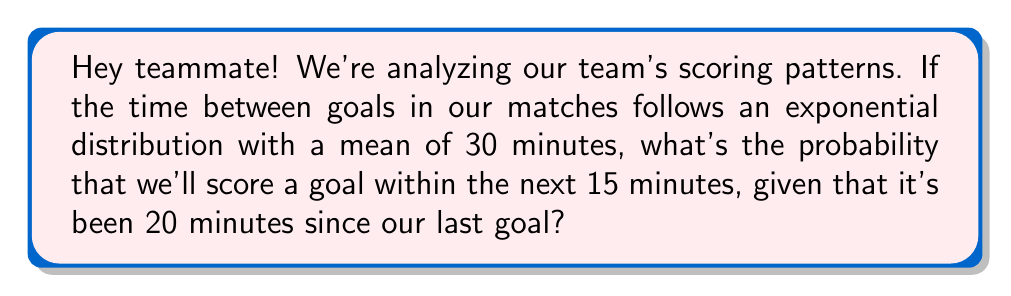Show me your answer to this math problem. Alright, let's break this down step-by-step:

1) The exponential distribution is memoryless, which means the probability of an event occurring in the next time interval is independent of how much time has already passed. So, the fact that 20 minutes have passed doesn't affect our calculation.

2) We're given that the mean time between goals is 30 minutes. For an exponential distribution, the mean is equal to $\frac{1}{\lambda}$, where $\lambda$ is the rate parameter. So:

   $\frac{1}{\lambda} = 30$
   $\lambda = \frac{1}{30}$

3) The probability of scoring a goal within time $t$ is given by the cumulative distribution function (CDF) of the exponential distribution:

   $P(T \leq t) = 1 - e^{-\lambda t}$

4) We want to find the probability of scoring within the next 15 minutes, so we'll use $t = 15$:

   $P(T \leq 15) = 1 - e^{-\frac{1}{30} \cdot 15}$

5) Let's calculate this:

   $P(T \leq 15) = 1 - e^{-0.5}$
                 $= 1 - 0.6065$
                 $= 0.3935$

6) Converting to a percentage:

   $0.3935 \cdot 100\% = 39.35\%$

So, there's about a 39.35% chance we'll score in the next 15 minutes!
Answer: 39.35% 